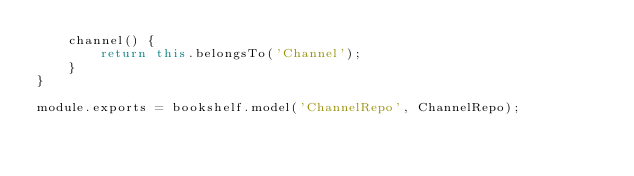Convert code to text. <code><loc_0><loc_0><loc_500><loc_500><_JavaScript_>    channel() {
        return this.belongsTo('Channel');
    }
}

module.exports = bookshelf.model('ChannelRepo', ChannelRepo);
</code> 